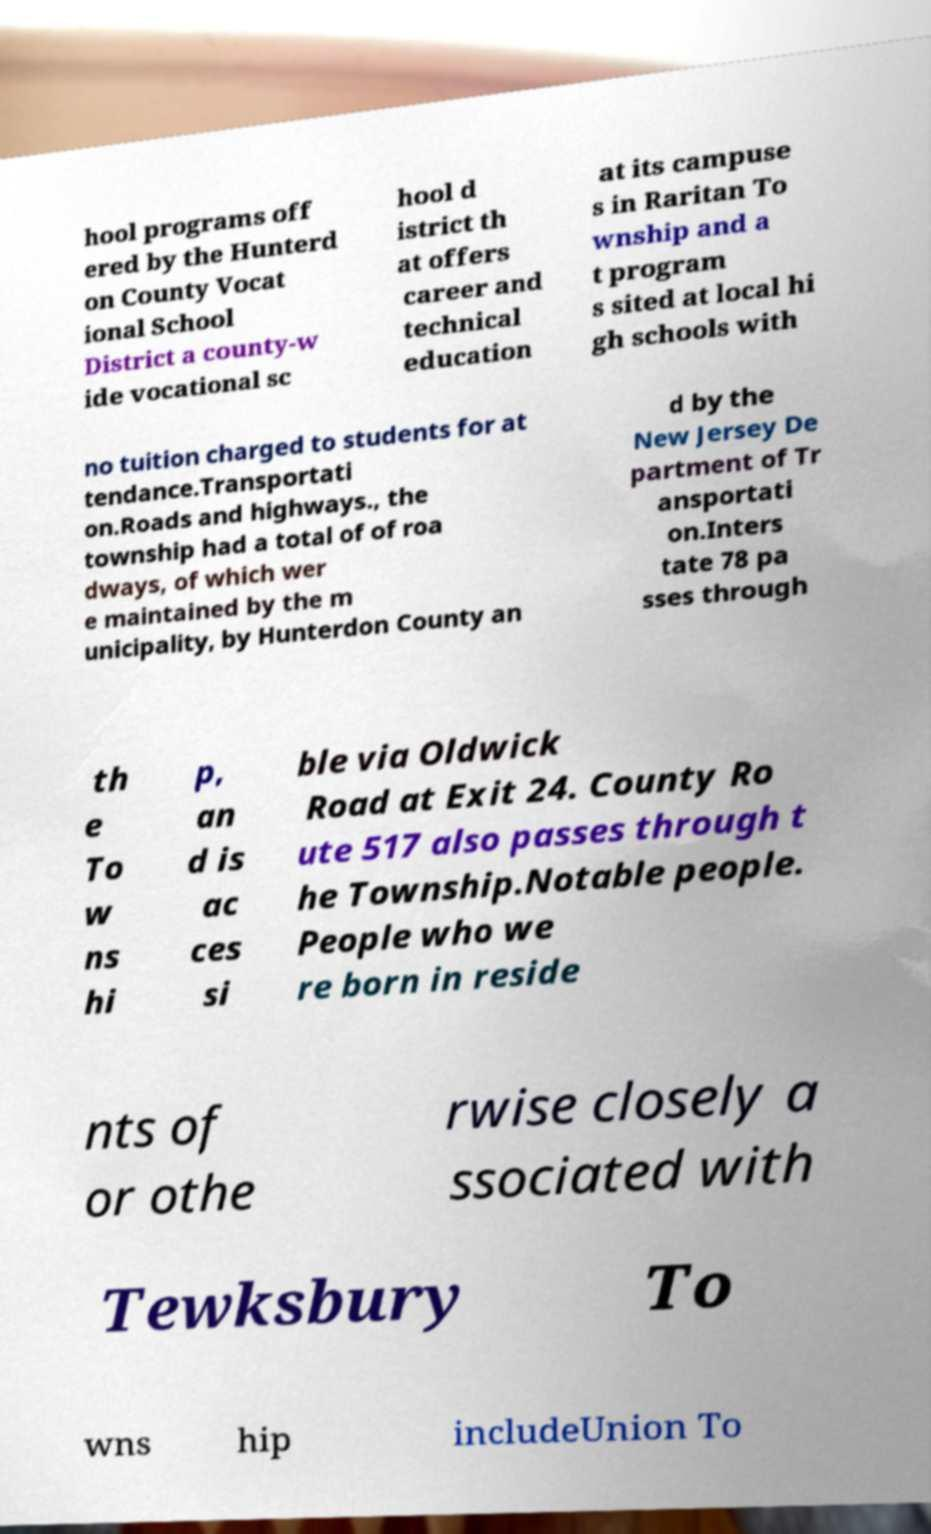Could you assist in decoding the text presented in this image and type it out clearly? hool programs off ered by the Hunterd on County Vocat ional School District a county-w ide vocational sc hool d istrict th at offers career and technical education at its campuse s in Raritan To wnship and a t program s sited at local hi gh schools with no tuition charged to students for at tendance.Transportati on.Roads and highways., the township had a total of of roa dways, of which wer e maintained by the m unicipality, by Hunterdon County an d by the New Jersey De partment of Tr ansportati on.Inters tate 78 pa sses through th e To w ns hi p, an d is ac ces si ble via Oldwick Road at Exit 24. County Ro ute 517 also passes through t he Township.Notable people. People who we re born in reside nts of or othe rwise closely a ssociated with Tewksbury To wns hip includeUnion To 